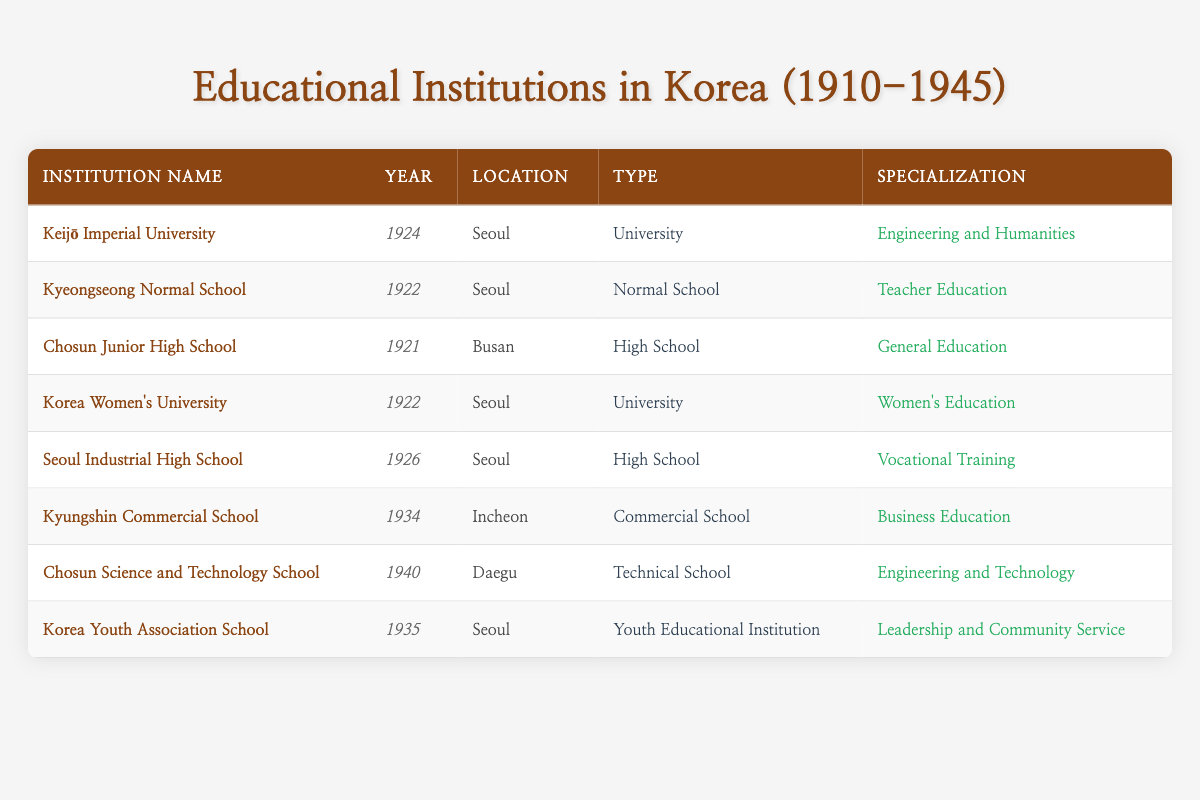What is the establishment year of Keijō Imperial University? The table directly lists the establishment year of Keijō Imperial University as 1924 in the "Year" column.
Answer: 1924 How many institutions were established in Seoul? By counting the entries in the "Location" column, we find that there are five institutions listed in Seoul: Keijō Imperial University, Kyeongseong Normal School, Korea Women's University, Seoul Industrial High School, and Korea Youth Association School.
Answer: 5 Is Chosun Science and Technology School a University? The "Type" column indicates that Chosun Science and Technology School is classified as a Technical School, not a University. Therefore, the answer is no.
Answer: No What types of educational institutions were established in 1922? Looking at the "Year" column for 1922, we find two institutions: Kyeongseong Normal School (Normal School) and Korea Women's University (University). In total, this gives us two different types of institutions established in that year.
Answer: 2 Which location has the highest number of institutions listed? By examining the "Location" column, Seoul has five institutions: Keijō Imperial University, Kyeongseong Normal School, Korea Women's University, Seoul Industrial High School, and Korea Youth Association School. Other locations like Busan, Incheon, and Daegu have only one or two institutions. Thus, Seoul has the most.
Answer: Seoul What is the earliest establishment year among the listed institutions? The earliest year visible in the "Year" column is 1921, which corresponds to Chosun Junior High School. This means that 1921 is the earliest establishment year noted among these institutions.
Answer: 1921 How many institutions specialize in women's education? The table contains one institution, Korea Women's University, that explicitly specializes in Women's Education. Thus the count is one.
Answer: 1 What is the difference in establishment years between Chosun Junior High School and Kyungshin Commercial School? Chosun Junior High School was established in 1921 and Kyungshin Commercial School was established in 1934. The difference is 1934 - 1921 = 13 years.
Answer: 13 